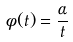<formula> <loc_0><loc_0><loc_500><loc_500>\phi ( t ) = \frac { \alpha } { t }</formula> 